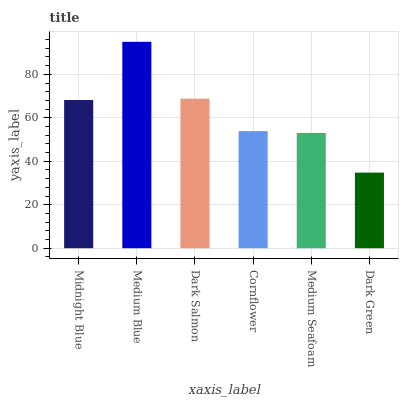Is Dark Green the minimum?
Answer yes or no. Yes. Is Medium Blue the maximum?
Answer yes or no. Yes. Is Dark Salmon the minimum?
Answer yes or no. No. Is Dark Salmon the maximum?
Answer yes or no. No. Is Medium Blue greater than Dark Salmon?
Answer yes or no. Yes. Is Dark Salmon less than Medium Blue?
Answer yes or no. Yes. Is Dark Salmon greater than Medium Blue?
Answer yes or no. No. Is Medium Blue less than Dark Salmon?
Answer yes or no. No. Is Midnight Blue the high median?
Answer yes or no. Yes. Is Cornflower the low median?
Answer yes or no. Yes. Is Cornflower the high median?
Answer yes or no. No. Is Midnight Blue the low median?
Answer yes or no. No. 